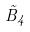Convert formula to latex. <formula><loc_0><loc_0><loc_500><loc_500>\tilde { B } _ { 4 }</formula> 